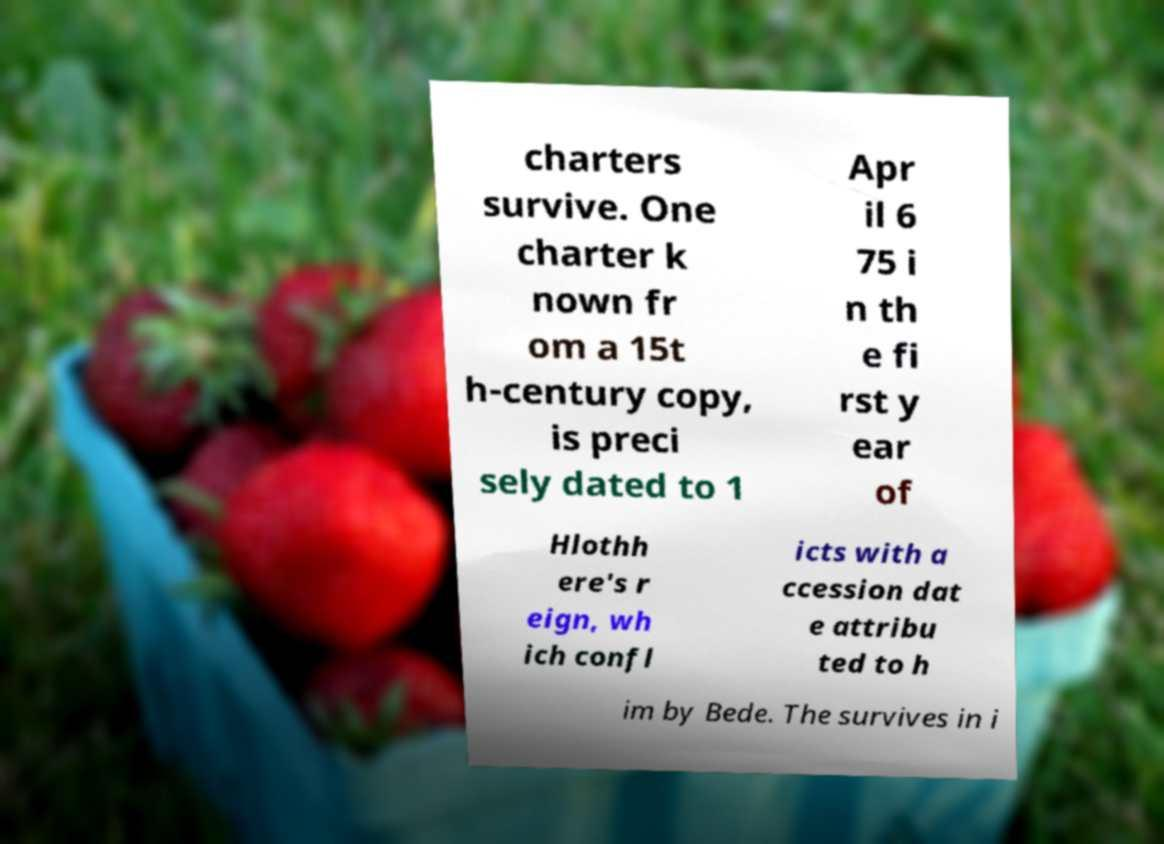I need the written content from this picture converted into text. Can you do that? charters survive. One charter k nown fr om a 15t h-century copy, is preci sely dated to 1 Apr il 6 75 i n th e fi rst y ear of Hlothh ere's r eign, wh ich confl icts with a ccession dat e attribu ted to h im by Bede. The survives in i 